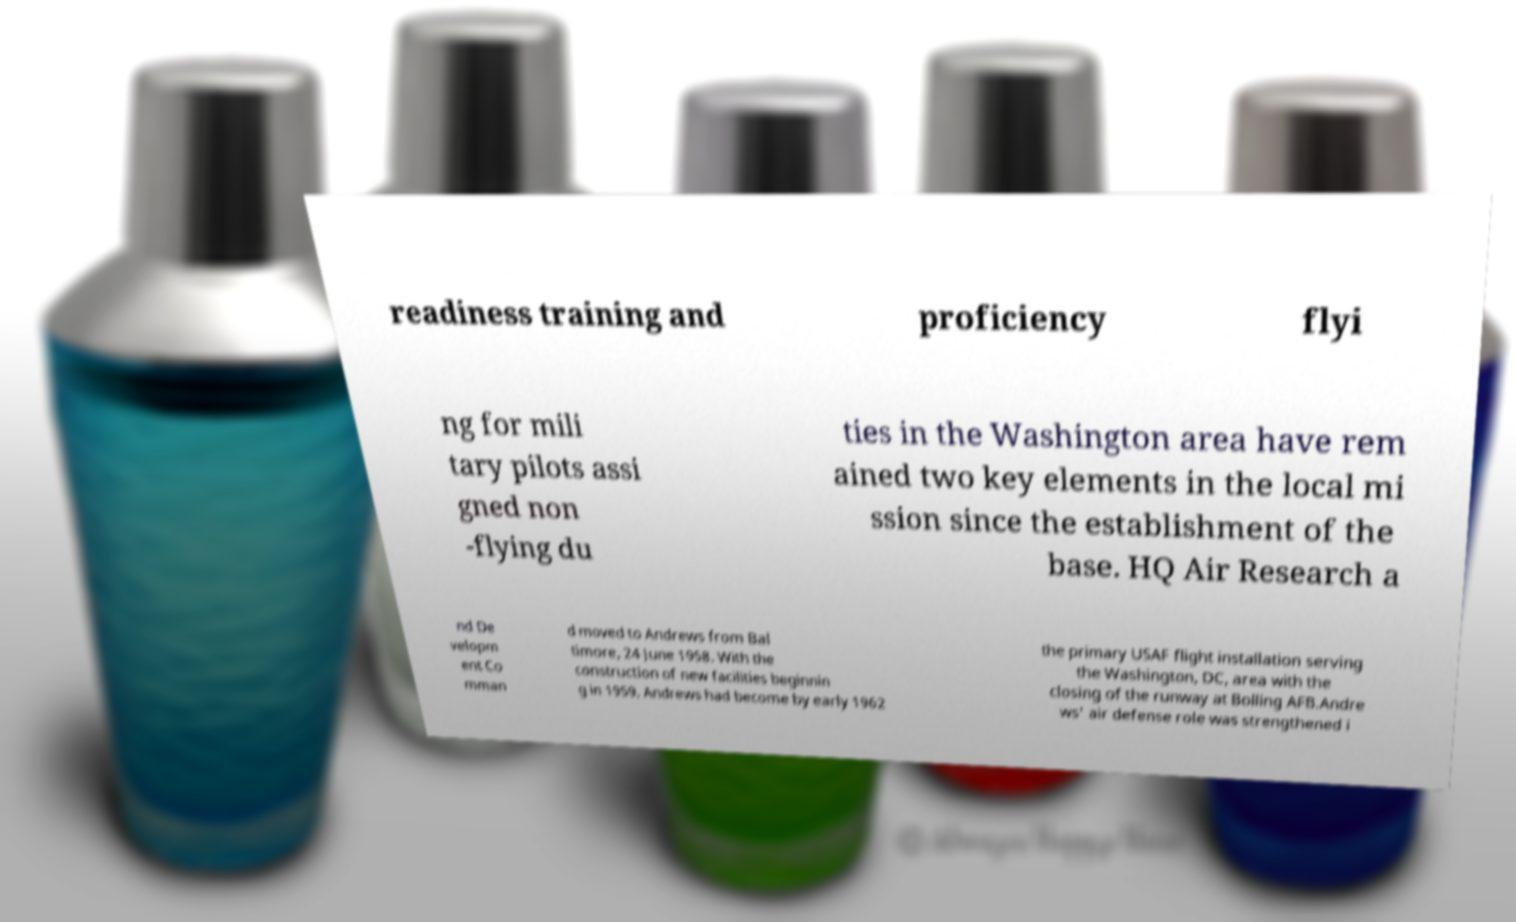Please read and relay the text visible in this image. What does it say? readiness training and proficiency flyi ng for mili tary pilots assi gned non -flying du ties in the Washington area have rem ained two key elements in the local mi ssion since the establishment of the base. HQ Air Research a nd De velopm ent Co mman d moved to Andrews from Bal timore, 24 June 1958. With the construction of new facilities beginnin g in 1959, Andrews had become by early 1962 the primary USAF flight installation serving the Washington, DC, area with the closing of the runway at Bolling AFB.Andre ws' air defense role was strengthened i 